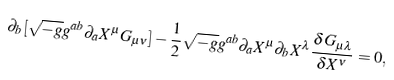Convert formula to latex. <formula><loc_0><loc_0><loc_500><loc_500>\partial _ { b } [ \sqrt { - g } g ^ { a b } \partial _ { a } X ^ { \mu } G _ { \mu \nu } ] - \frac { 1 } { 2 } \sqrt { - g } g ^ { a b } \partial _ { a } X ^ { \mu } \partial _ { b } X ^ { \lambda } \frac { \delta G _ { \mu \lambda } } { \delta X ^ { \nu } } = 0 ,</formula> 